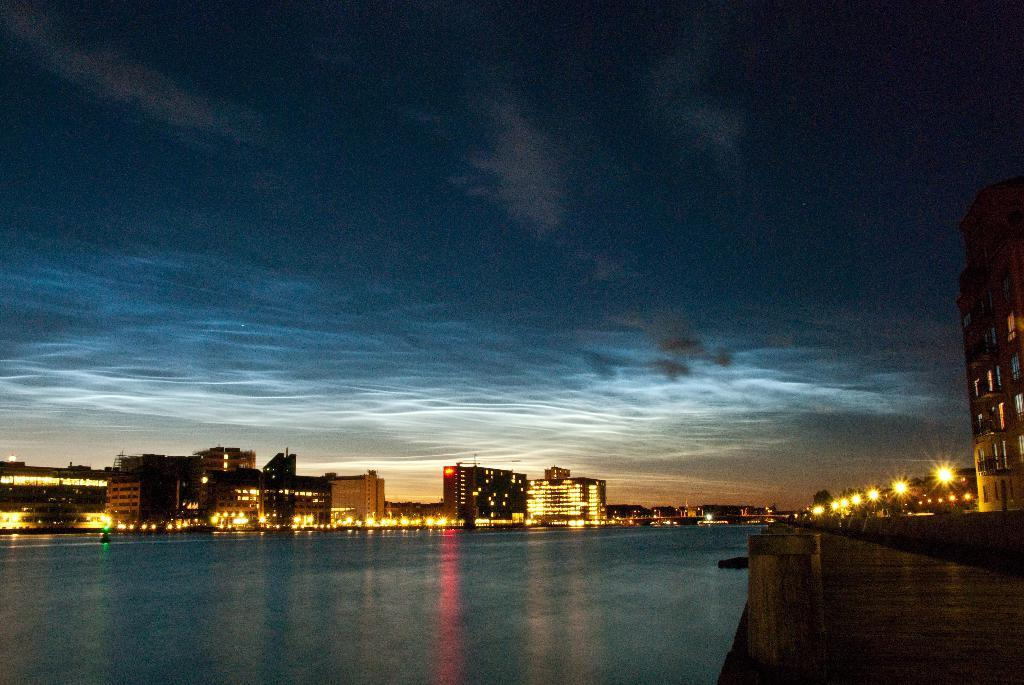What type of structures can be seen in the image? There are buildings in the image. What natural element is visible in the image? There is water visible in the image. What artificial light sources are present in the image? There are lights in the image. What is the condition of the sky in the image? The sky is cloudy in the image. Can you tell me how many drains are visible in the image? There are no drains present in the image. Is there a person visible in the image? There is no person visible in the image. What type of toy can be seen in the image? There is no toy, such as a doll, present in the image. 